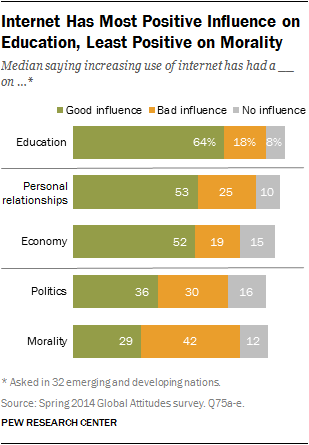List a handful of essential elements in this visual. The survey found that 64% of people believe that the internet has a positive influence on education. There is a significant difference of opinion among individuals who believe that the internet has a positive or negative impact on politics. 